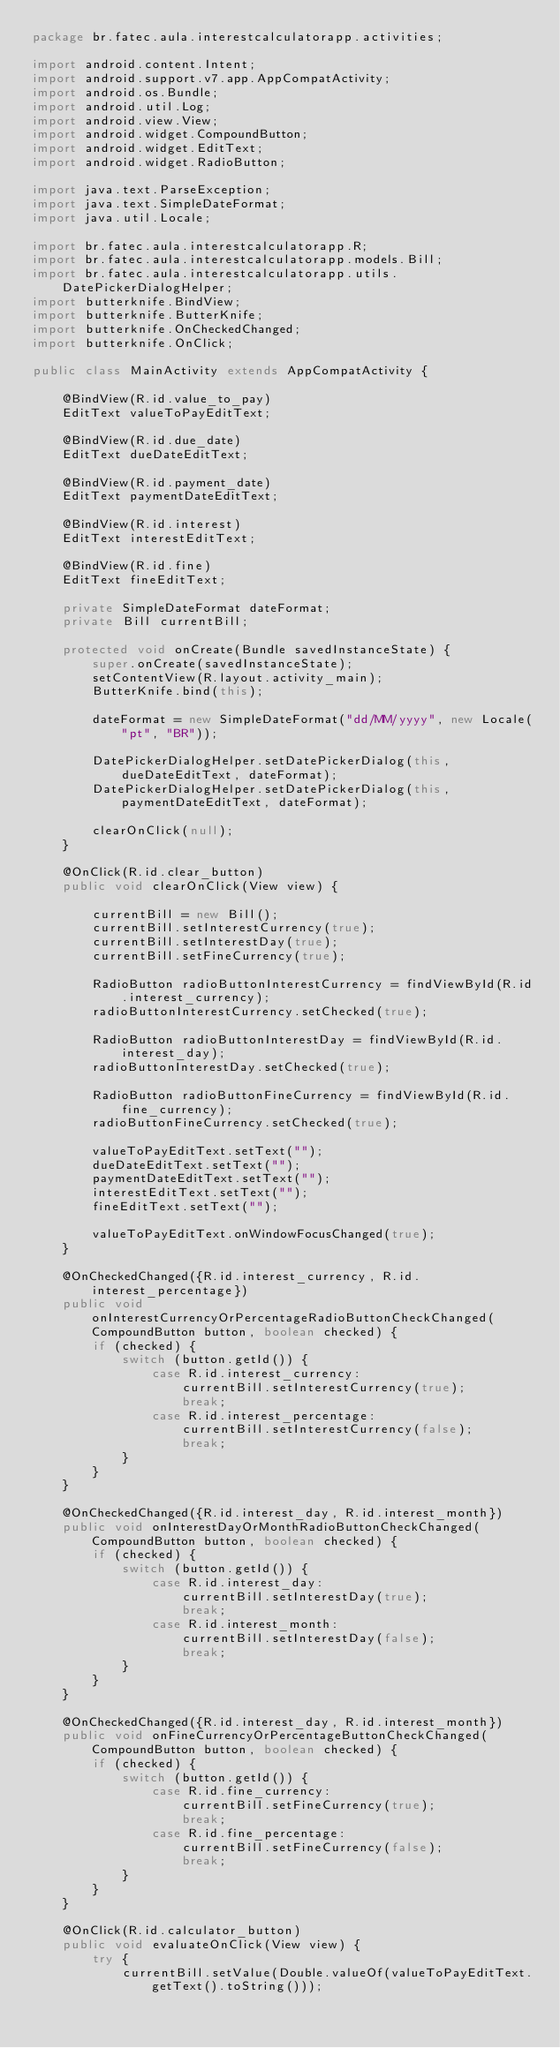<code> <loc_0><loc_0><loc_500><loc_500><_Java_>package br.fatec.aula.interestcalculatorapp.activities;

import android.content.Intent;
import android.support.v7.app.AppCompatActivity;
import android.os.Bundle;
import android.util.Log;
import android.view.View;
import android.widget.CompoundButton;
import android.widget.EditText;
import android.widget.RadioButton;

import java.text.ParseException;
import java.text.SimpleDateFormat;
import java.util.Locale;

import br.fatec.aula.interestcalculatorapp.R;
import br.fatec.aula.interestcalculatorapp.models.Bill;
import br.fatec.aula.interestcalculatorapp.utils.DatePickerDialogHelper;
import butterknife.BindView;
import butterknife.ButterKnife;
import butterknife.OnCheckedChanged;
import butterknife.OnClick;

public class MainActivity extends AppCompatActivity {

    @BindView(R.id.value_to_pay)
    EditText valueToPayEditText;

    @BindView(R.id.due_date)
    EditText dueDateEditText;

    @BindView(R.id.payment_date)
    EditText paymentDateEditText;

    @BindView(R.id.interest)
    EditText interestEditText;

    @BindView(R.id.fine)
    EditText fineEditText;

    private SimpleDateFormat dateFormat;
    private Bill currentBill;

    protected void onCreate(Bundle savedInstanceState) {
        super.onCreate(savedInstanceState);
        setContentView(R.layout.activity_main);
        ButterKnife.bind(this);

        dateFormat = new SimpleDateFormat("dd/MM/yyyy", new Locale("pt", "BR"));

        DatePickerDialogHelper.setDatePickerDialog(this, dueDateEditText, dateFormat);
        DatePickerDialogHelper.setDatePickerDialog(this, paymentDateEditText, dateFormat);

        clearOnClick(null);
    }

    @OnClick(R.id.clear_button)
    public void clearOnClick(View view) {

        currentBill = new Bill();
        currentBill.setInterestCurrency(true);
        currentBill.setInterestDay(true);
        currentBill.setFineCurrency(true);

        RadioButton radioButtonInterestCurrency = findViewById(R.id.interest_currency);
        radioButtonInterestCurrency.setChecked(true);

        RadioButton radioButtonInterestDay = findViewById(R.id.interest_day);
        radioButtonInterestDay.setChecked(true);

        RadioButton radioButtonFineCurrency = findViewById(R.id.fine_currency);
        radioButtonFineCurrency.setChecked(true);

        valueToPayEditText.setText("");
        dueDateEditText.setText("");
        paymentDateEditText.setText("");
        interestEditText.setText("");
        fineEditText.setText("");

        valueToPayEditText.onWindowFocusChanged(true);
    }

    @OnCheckedChanged({R.id.interest_currency, R.id.interest_percentage})
    public void onInterestCurrencyOrPercentageRadioButtonCheckChanged(CompoundButton button, boolean checked) {
        if (checked) {
            switch (button.getId()) {
                case R.id.interest_currency:
                    currentBill.setInterestCurrency(true);
                    break;
                case R.id.interest_percentage:
                    currentBill.setInterestCurrency(false);
                    break;
            }
        }
    }

    @OnCheckedChanged({R.id.interest_day, R.id.interest_month})
    public void onInterestDayOrMonthRadioButtonCheckChanged(CompoundButton button, boolean checked) {
        if (checked) {
            switch (button.getId()) {
                case R.id.interest_day:
                    currentBill.setInterestDay(true);
                    break;
                case R.id.interest_month:
                    currentBill.setInterestDay(false);
                    break;
            }
        }
    }

    @OnCheckedChanged({R.id.interest_day, R.id.interest_month})
    public void onFineCurrencyOrPercentageButtonCheckChanged(CompoundButton button, boolean checked) {
        if (checked) {
            switch (button.getId()) {
                case R.id.fine_currency:
                    currentBill.setFineCurrency(true);
                    break;
                case R.id.fine_percentage:
                    currentBill.setFineCurrency(false);
                    break;
            }
        }
    }

    @OnClick(R.id.calculator_button)
    public void evaluateOnClick(View view) {
        try {
            currentBill.setValue(Double.valueOf(valueToPayEditText.getText().toString()));</code> 